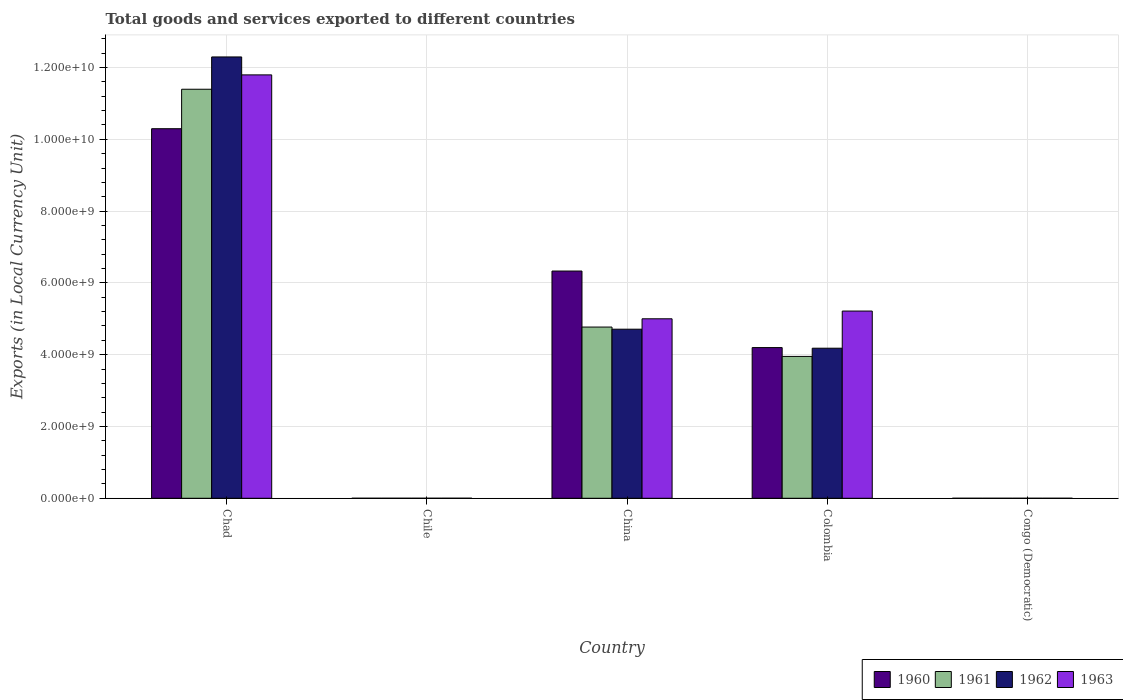How many different coloured bars are there?
Offer a very short reply. 4. How many groups of bars are there?
Make the answer very short. 5. Are the number of bars per tick equal to the number of legend labels?
Your response must be concise. Yes. How many bars are there on the 5th tick from the left?
Your answer should be very brief. 4. How many bars are there on the 2nd tick from the right?
Provide a succinct answer. 4. What is the label of the 4th group of bars from the left?
Provide a short and direct response. Colombia. What is the Amount of goods and services exports in 1960 in China?
Keep it short and to the point. 6.33e+09. Across all countries, what is the maximum Amount of goods and services exports in 1961?
Ensure brevity in your answer.  1.14e+1. Across all countries, what is the minimum Amount of goods and services exports in 1962?
Offer a terse response. 6.15126409684308e-5. In which country was the Amount of goods and services exports in 1960 maximum?
Make the answer very short. Chad. In which country was the Amount of goods and services exports in 1961 minimum?
Provide a succinct answer. Congo (Democratic). What is the total Amount of goods and services exports in 1962 in the graph?
Keep it short and to the point. 2.12e+1. What is the difference between the Amount of goods and services exports in 1961 in Chad and that in Colombia?
Keep it short and to the point. 7.44e+09. What is the difference between the Amount of goods and services exports in 1960 in Congo (Democratic) and the Amount of goods and services exports in 1961 in Chad?
Provide a succinct answer. -1.14e+1. What is the average Amount of goods and services exports in 1963 per country?
Offer a very short reply. 4.40e+09. What is the difference between the Amount of goods and services exports of/in 1960 and Amount of goods and services exports of/in 1961 in Chad?
Keep it short and to the point. -1.10e+09. In how many countries, is the Amount of goods and services exports in 1962 greater than 12000000000 LCU?
Provide a short and direct response. 1. What is the ratio of the Amount of goods and services exports in 1961 in Chile to that in China?
Keep it short and to the point. 0. What is the difference between the highest and the second highest Amount of goods and services exports in 1962?
Make the answer very short. 7.58e+09. What is the difference between the highest and the lowest Amount of goods and services exports in 1963?
Give a very brief answer. 1.18e+1. Is the sum of the Amount of goods and services exports in 1962 in China and Colombia greater than the maximum Amount of goods and services exports in 1961 across all countries?
Give a very brief answer. No. Is it the case that in every country, the sum of the Amount of goods and services exports in 1963 and Amount of goods and services exports in 1962 is greater than the Amount of goods and services exports in 1960?
Provide a succinct answer. Yes. What is the difference between two consecutive major ticks on the Y-axis?
Your answer should be compact. 2.00e+09. Are the values on the major ticks of Y-axis written in scientific E-notation?
Your response must be concise. Yes. Does the graph contain any zero values?
Your answer should be very brief. No. Does the graph contain grids?
Give a very brief answer. Yes. What is the title of the graph?
Offer a very short reply. Total goods and services exported to different countries. Does "1965" appear as one of the legend labels in the graph?
Make the answer very short. No. What is the label or title of the Y-axis?
Provide a short and direct response. Exports (in Local Currency Unit). What is the Exports (in Local Currency Unit) of 1960 in Chad?
Make the answer very short. 1.03e+1. What is the Exports (in Local Currency Unit) in 1961 in Chad?
Provide a short and direct response. 1.14e+1. What is the Exports (in Local Currency Unit) of 1962 in Chad?
Keep it short and to the point. 1.23e+1. What is the Exports (in Local Currency Unit) of 1963 in Chad?
Your answer should be compact. 1.18e+1. What is the Exports (in Local Currency Unit) in 1960 in Chile?
Offer a very short reply. 6.00e+05. What is the Exports (in Local Currency Unit) in 1963 in Chile?
Your answer should be very brief. 1.10e+06. What is the Exports (in Local Currency Unit) of 1960 in China?
Your answer should be compact. 6.33e+09. What is the Exports (in Local Currency Unit) of 1961 in China?
Offer a very short reply. 4.77e+09. What is the Exports (in Local Currency Unit) in 1962 in China?
Ensure brevity in your answer.  4.71e+09. What is the Exports (in Local Currency Unit) in 1963 in China?
Offer a very short reply. 5.00e+09. What is the Exports (in Local Currency Unit) of 1960 in Colombia?
Provide a short and direct response. 4.20e+09. What is the Exports (in Local Currency Unit) of 1961 in Colombia?
Provide a short and direct response. 3.95e+09. What is the Exports (in Local Currency Unit) of 1962 in Colombia?
Give a very brief answer. 4.18e+09. What is the Exports (in Local Currency Unit) of 1963 in Colombia?
Make the answer very short. 5.22e+09. What is the Exports (in Local Currency Unit) of 1960 in Congo (Democratic)?
Give a very brief answer. 0. What is the Exports (in Local Currency Unit) in 1961 in Congo (Democratic)?
Give a very brief answer. 5.32500016561244e-5. What is the Exports (in Local Currency Unit) of 1962 in Congo (Democratic)?
Make the answer very short. 6.15126409684308e-5. What is the Exports (in Local Currency Unit) of 1963 in Congo (Democratic)?
Give a very brief answer. 0. Across all countries, what is the maximum Exports (in Local Currency Unit) of 1960?
Your response must be concise. 1.03e+1. Across all countries, what is the maximum Exports (in Local Currency Unit) in 1961?
Offer a terse response. 1.14e+1. Across all countries, what is the maximum Exports (in Local Currency Unit) in 1962?
Provide a succinct answer. 1.23e+1. Across all countries, what is the maximum Exports (in Local Currency Unit) in 1963?
Your answer should be very brief. 1.18e+1. Across all countries, what is the minimum Exports (in Local Currency Unit) of 1960?
Provide a short and direct response. 0. Across all countries, what is the minimum Exports (in Local Currency Unit) of 1961?
Your answer should be compact. 5.32500016561244e-5. Across all countries, what is the minimum Exports (in Local Currency Unit) of 1962?
Give a very brief answer. 6.15126409684308e-5. Across all countries, what is the minimum Exports (in Local Currency Unit) of 1963?
Your response must be concise. 0. What is the total Exports (in Local Currency Unit) of 1960 in the graph?
Your response must be concise. 2.08e+1. What is the total Exports (in Local Currency Unit) in 1961 in the graph?
Offer a very short reply. 2.01e+1. What is the total Exports (in Local Currency Unit) of 1962 in the graph?
Make the answer very short. 2.12e+1. What is the total Exports (in Local Currency Unit) of 1963 in the graph?
Provide a short and direct response. 2.20e+1. What is the difference between the Exports (in Local Currency Unit) of 1960 in Chad and that in Chile?
Your response must be concise. 1.03e+1. What is the difference between the Exports (in Local Currency Unit) in 1961 in Chad and that in Chile?
Provide a short and direct response. 1.14e+1. What is the difference between the Exports (in Local Currency Unit) in 1962 in Chad and that in Chile?
Offer a terse response. 1.23e+1. What is the difference between the Exports (in Local Currency Unit) of 1963 in Chad and that in Chile?
Your answer should be compact. 1.18e+1. What is the difference between the Exports (in Local Currency Unit) in 1960 in Chad and that in China?
Your response must be concise. 3.97e+09. What is the difference between the Exports (in Local Currency Unit) of 1961 in Chad and that in China?
Offer a terse response. 6.62e+09. What is the difference between the Exports (in Local Currency Unit) of 1962 in Chad and that in China?
Keep it short and to the point. 7.58e+09. What is the difference between the Exports (in Local Currency Unit) in 1963 in Chad and that in China?
Provide a short and direct response. 6.79e+09. What is the difference between the Exports (in Local Currency Unit) in 1960 in Chad and that in Colombia?
Your answer should be compact. 6.10e+09. What is the difference between the Exports (in Local Currency Unit) in 1961 in Chad and that in Colombia?
Ensure brevity in your answer.  7.44e+09. What is the difference between the Exports (in Local Currency Unit) in 1962 in Chad and that in Colombia?
Your response must be concise. 8.11e+09. What is the difference between the Exports (in Local Currency Unit) of 1963 in Chad and that in Colombia?
Your response must be concise. 6.58e+09. What is the difference between the Exports (in Local Currency Unit) in 1960 in Chad and that in Congo (Democratic)?
Provide a succinct answer. 1.03e+1. What is the difference between the Exports (in Local Currency Unit) of 1961 in Chad and that in Congo (Democratic)?
Provide a succinct answer. 1.14e+1. What is the difference between the Exports (in Local Currency Unit) of 1962 in Chad and that in Congo (Democratic)?
Your answer should be very brief. 1.23e+1. What is the difference between the Exports (in Local Currency Unit) of 1963 in Chad and that in Congo (Democratic)?
Keep it short and to the point. 1.18e+1. What is the difference between the Exports (in Local Currency Unit) of 1960 in Chile and that in China?
Offer a terse response. -6.33e+09. What is the difference between the Exports (in Local Currency Unit) in 1961 in Chile and that in China?
Provide a short and direct response. -4.77e+09. What is the difference between the Exports (in Local Currency Unit) of 1962 in Chile and that in China?
Give a very brief answer. -4.71e+09. What is the difference between the Exports (in Local Currency Unit) of 1963 in Chile and that in China?
Provide a short and direct response. -5.00e+09. What is the difference between the Exports (in Local Currency Unit) of 1960 in Chile and that in Colombia?
Ensure brevity in your answer.  -4.20e+09. What is the difference between the Exports (in Local Currency Unit) in 1961 in Chile and that in Colombia?
Your answer should be compact. -3.95e+09. What is the difference between the Exports (in Local Currency Unit) in 1962 in Chile and that in Colombia?
Make the answer very short. -4.18e+09. What is the difference between the Exports (in Local Currency Unit) in 1963 in Chile and that in Colombia?
Offer a terse response. -5.21e+09. What is the difference between the Exports (in Local Currency Unit) of 1960 in Chile and that in Congo (Democratic)?
Your answer should be very brief. 6.00e+05. What is the difference between the Exports (in Local Currency Unit) in 1961 in Chile and that in Congo (Democratic)?
Ensure brevity in your answer.  6.00e+05. What is the difference between the Exports (in Local Currency Unit) in 1962 in Chile and that in Congo (Democratic)?
Provide a succinct answer. 7.00e+05. What is the difference between the Exports (in Local Currency Unit) of 1963 in Chile and that in Congo (Democratic)?
Your answer should be compact. 1.10e+06. What is the difference between the Exports (in Local Currency Unit) of 1960 in China and that in Colombia?
Make the answer very short. 2.13e+09. What is the difference between the Exports (in Local Currency Unit) of 1961 in China and that in Colombia?
Your answer should be compact. 8.18e+08. What is the difference between the Exports (in Local Currency Unit) of 1962 in China and that in Colombia?
Offer a terse response. 5.30e+08. What is the difference between the Exports (in Local Currency Unit) in 1963 in China and that in Colombia?
Give a very brief answer. -2.16e+08. What is the difference between the Exports (in Local Currency Unit) of 1960 in China and that in Congo (Democratic)?
Your answer should be compact. 6.33e+09. What is the difference between the Exports (in Local Currency Unit) of 1961 in China and that in Congo (Democratic)?
Your answer should be very brief. 4.77e+09. What is the difference between the Exports (in Local Currency Unit) in 1962 in China and that in Congo (Democratic)?
Offer a terse response. 4.71e+09. What is the difference between the Exports (in Local Currency Unit) in 1963 in China and that in Congo (Democratic)?
Your answer should be very brief. 5.00e+09. What is the difference between the Exports (in Local Currency Unit) of 1960 in Colombia and that in Congo (Democratic)?
Your response must be concise. 4.20e+09. What is the difference between the Exports (in Local Currency Unit) in 1961 in Colombia and that in Congo (Democratic)?
Provide a short and direct response. 3.95e+09. What is the difference between the Exports (in Local Currency Unit) of 1962 in Colombia and that in Congo (Democratic)?
Ensure brevity in your answer.  4.18e+09. What is the difference between the Exports (in Local Currency Unit) of 1963 in Colombia and that in Congo (Democratic)?
Give a very brief answer. 5.22e+09. What is the difference between the Exports (in Local Currency Unit) in 1960 in Chad and the Exports (in Local Currency Unit) in 1961 in Chile?
Ensure brevity in your answer.  1.03e+1. What is the difference between the Exports (in Local Currency Unit) of 1960 in Chad and the Exports (in Local Currency Unit) of 1962 in Chile?
Your response must be concise. 1.03e+1. What is the difference between the Exports (in Local Currency Unit) of 1960 in Chad and the Exports (in Local Currency Unit) of 1963 in Chile?
Keep it short and to the point. 1.03e+1. What is the difference between the Exports (in Local Currency Unit) in 1961 in Chad and the Exports (in Local Currency Unit) in 1962 in Chile?
Give a very brief answer. 1.14e+1. What is the difference between the Exports (in Local Currency Unit) in 1961 in Chad and the Exports (in Local Currency Unit) in 1963 in Chile?
Give a very brief answer. 1.14e+1. What is the difference between the Exports (in Local Currency Unit) in 1962 in Chad and the Exports (in Local Currency Unit) in 1963 in Chile?
Offer a very short reply. 1.23e+1. What is the difference between the Exports (in Local Currency Unit) of 1960 in Chad and the Exports (in Local Currency Unit) of 1961 in China?
Keep it short and to the point. 5.53e+09. What is the difference between the Exports (in Local Currency Unit) of 1960 in Chad and the Exports (in Local Currency Unit) of 1962 in China?
Provide a short and direct response. 5.59e+09. What is the difference between the Exports (in Local Currency Unit) in 1960 in Chad and the Exports (in Local Currency Unit) in 1963 in China?
Make the answer very short. 5.30e+09. What is the difference between the Exports (in Local Currency Unit) in 1961 in Chad and the Exports (in Local Currency Unit) in 1962 in China?
Provide a short and direct response. 6.68e+09. What is the difference between the Exports (in Local Currency Unit) in 1961 in Chad and the Exports (in Local Currency Unit) in 1963 in China?
Make the answer very short. 6.39e+09. What is the difference between the Exports (in Local Currency Unit) of 1962 in Chad and the Exports (in Local Currency Unit) of 1963 in China?
Keep it short and to the point. 7.29e+09. What is the difference between the Exports (in Local Currency Unit) of 1960 in Chad and the Exports (in Local Currency Unit) of 1961 in Colombia?
Ensure brevity in your answer.  6.34e+09. What is the difference between the Exports (in Local Currency Unit) of 1960 in Chad and the Exports (in Local Currency Unit) of 1962 in Colombia?
Offer a very short reply. 6.11e+09. What is the difference between the Exports (in Local Currency Unit) in 1960 in Chad and the Exports (in Local Currency Unit) in 1963 in Colombia?
Your response must be concise. 5.08e+09. What is the difference between the Exports (in Local Currency Unit) of 1961 in Chad and the Exports (in Local Currency Unit) of 1962 in Colombia?
Ensure brevity in your answer.  7.21e+09. What is the difference between the Exports (in Local Currency Unit) of 1961 in Chad and the Exports (in Local Currency Unit) of 1963 in Colombia?
Provide a short and direct response. 6.18e+09. What is the difference between the Exports (in Local Currency Unit) of 1962 in Chad and the Exports (in Local Currency Unit) of 1963 in Colombia?
Offer a terse response. 7.08e+09. What is the difference between the Exports (in Local Currency Unit) of 1960 in Chad and the Exports (in Local Currency Unit) of 1961 in Congo (Democratic)?
Make the answer very short. 1.03e+1. What is the difference between the Exports (in Local Currency Unit) of 1960 in Chad and the Exports (in Local Currency Unit) of 1962 in Congo (Democratic)?
Provide a succinct answer. 1.03e+1. What is the difference between the Exports (in Local Currency Unit) in 1960 in Chad and the Exports (in Local Currency Unit) in 1963 in Congo (Democratic)?
Give a very brief answer. 1.03e+1. What is the difference between the Exports (in Local Currency Unit) in 1961 in Chad and the Exports (in Local Currency Unit) in 1962 in Congo (Democratic)?
Keep it short and to the point. 1.14e+1. What is the difference between the Exports (in Local Currency Unit) in 1961 in Chad and the Exports (in Local Currency Unit) in 1963 in Congo (Democratic)?
Keep it short and to the point. 1.14e+1. What is the difference between the Exports (in Local Currency Unit) of 1962 in Chad and the Exports (in Local Currency Unit) of 1963 in Congo (Democratic)?
Ensure brevity in your answer.  1.23e+1. What is the difference between the Exports (in Local Currency Unit) of 1960 in Chile and the Exports (in Local Currency Unit) of 1961 in China?
Offer a terse response. -4.77e+09. What is the difference between the Exports (in Local Currency Unit) of 1960 in Chile and the Exports (in Local Currency Unit) of 1962 in China?
Keep it short and to the point. -4.71e+09. What is the difference between the Exports (in Local Currency Unit) in 1960 in Chile and the Exports (in Local Currency Unit) in 1963 in China?
Make the answer very short. -5.00e+09. What is the difference between the Exports (in Local Currency Unit) in 1961 in Chile and the Exports (in Local Currency Unit) in 1962 in China?
Provide a short and direct response. -4.71e+09. What is the difference between the Exports (in Local Currency Unit) of 1961 in Chile and the Exports (in Local Currency Unit) of 1963 in China?
Provide a short and direct response. -5.00e+09. What is the difference between the Exports (in Local Currency Unit) in 1962 in Chile and the Exports (in Local Currency Unit) in 1963 in China?
Give a very brief answer. -5.00e+09. What is the difference between the Exports (in Local Currency Unit) of 1960 in Chile and the Exports (in Local Currency Unit) of 1961 in Colombia?
Make the answer very short. -3.95e+09. What is the difference between the Exports (in Local Currency Unit) in 1960 in Chile and the Exports (in Local Currency Unit) in 1962 in Colombia?
Your answer should be compact. -4.18e+09. What is the difference between the Exports (in Local Currency Unit) in 1960 in Chile and the Exports (in Local Currency Unit) in 1963 in Colombia?
Ensure brevity in your answer.  -5.21e+09. What is the difference between the Exports (in Local Currency Unit) in 1961 in Chile and the Exports (in Local Currency Unit) in 1962 in Colombia?
Provide a short and direct response. -4.18e+09. What is the difference between the Exports (in Local Currency Unit) of 1961 in Chile and the Exports (in Local Currency Unit) of 1963 in Colombia?
Provide a succinct answer. -5.21e+09. What is the difference between the Exports (in Local Currency Unit) of 1962 in Chile and the Exports (in Local Currency Unit) of 1963 in Colombia?
Offer a very short reply. -5.21e+09. What is the difference between the Exports (in Local Currency Unit) in 1960 in Chile and the Exports (in Local Currency Unit) in 1961 in Congo (Democratic)?
Make the answer very short. 6.00e+05. What is the difference between the Exports (in Local Currency Unit) in 1960 in Chile and the Exports (in Local Currency Unit) in 1962 in Congo (Democratic)?
Offer a terse response. 6.00e+05. What is the difference between the Exports (in Local Currency Unit) in 1960 in Chile and the Exports (in Local Currency Unit) in 1963 in Congo (Democratic)?
Offer a terse response. 6.00e+05. What is the difference between the Exports (in Local Currency Unit) in 1961 in Chile and the Exports (in Local Currency Unit) in 1962 in Congo (Democratic)?
Your response must be concise. 6.00e+05. What is the difference between the Exports (in Local Currency Unit) in 1961 in Chile and the Exports (in Local Currency Unit) in 1963 in Congo (Democratic)?
Keep it short and to the point. 6.00e+05. What is the difference between the Exports (in Local Currency Unit) in 1962 in Chile and the Exports (in Local Currency Unit) in 1963 in Congo (Democratic)?
Provide a short and direct response. 7.00e+05. What is the difference between the Exports (in Local Currency Unit) in 1960 in China and the Exports (in Local Currency Unit) in 1961 in Colombia?
Your answer should be very brief. 2.38e+09. What is the difference between the Exports (in Local Currency Unit) in 1960 in China and the Exports (in Local Currency Unit) in 1962 in Colombia?
Provide a succinct answer. 2.15e+09. What is the difference between the Exports (in Local Currency Unit) in 1960 in China and the Exports (in Local Currency Unit) in 1963 in Colombia?
Offer a terse response. 1.11e+09. What is the difference between the Exports (in Local Currency Unit) of 1961 in China and the Exports (in Local Currency Unit) of 1962 in Colombia?
Keep it short and to the point. 5.90e+08. What is the difference between the Exports (in Local Currency Unit) of 1961 in China and the Exports (in Local Currency Unit) of 1963 in Colombia?
Offer a terse response. -4.46e+08. What is the difference between the Exports (in Local Currency Unit) of 1962 in China and the Exports (in Local Currency Unit) of 1963 in Colombia?
Ensure brevity in your answer.  -5.06e+08. What is the difference between the Exports (in Local Currency Unit) of 1960 in China and the Exports (in Local Currency Unit) of 1961 in Congo (Democratic)?
Your response must be concise. 6.33e+09. What is the difference between the Exports (in Local Currency Unit) in 1960 in China and the Exports (in Local Currency Unit) in 1962 in Congo (Democratic)?
Provide a short and direct response. 6.33e+09. What is the difference between the Exports (in Local Currency Unit) of 1960 in China and the Exports (in Local Currency Unit) of 1963 in Congo (Democratic)?
Keep it short and to the point. 6.33e+09. What is the difference between the Exports (in Local Currency Unit) in 1961 in China and the Exports (in Local Currency Unit) in 1962 in Congo (Democratic)?
Your answer should be very brief. 4.77e+09. What is the difference between the Exports (in Local Currency Unit) of 1961 in China and the Exports (in Local Currency Unit) of 1963 in Congo (Democratic)?
Provide a short and direct response. 4.77e+09. What is the difference between the Exports (in Local Currency Unit) of 1962 in China and the Exports (in Local Currency Unit) of 1963 in Congo (Democratic)?
Your answer should be compact. 4.71e+09. What is the difference between the Exports (in Local Currency Unit) of 1960 in Colombia and the Exports (in Local Currency Unit) of 1961 in Congo (Democratic)?
Your answer should be very brief. 4.20e+09. What is the difference between the Exports (in Local Currency Unit) of 1960 in Colombia and the Exports (in Local Currency Unit) of 1962 in Congo (Democratic)?
Provide a short and direct response. 4.20e+09. What is the difference between the Exports (in Local Currency Unit) in 1960 in Colombia and the Exports (in Local Currency Unit) in 1963 in Congo (Democratic)?
Ensure brevity in your answer.  4.20e+09. What is the difference between the Exports (in Local Currency Unit) in 1961 in Colombia and the Exports (in Local Currency Unit) in 1962 in Congo (Democratic)?
Give a very brief answer. 3.95e+09. What is the difference between the Exports (in Local Currency Unit) in 1961 in Colombia and the Exports (in Local Currency Unit) in 1963 in Congo (Democratic)?
Your response must be concise. 3.95e+09. What is the difference between the Exports (in Local Currency Unit) in 1962 in Colombia and the Exports (in Local Currency Unit) in 1963 in Congo (Democratic)?
Your response must be concise. 4.18e+09. What is the average Exports (in Local Currency Unit) of 1960 per country?
Your response must be concise. 4.16e+09. What is the average Exports (in Local Currency Unit) in 1961 per country?
Your answer should be compact. 4.02e+09. What is the average Exports (in Local Currency Unit) in 1962 per country?
Provide a succinct answer. 4.24e+09. What is the average Exports (in Local Currency Unit) in 1963 per country?
Offer a terse response. 4.40e+09. What is the difference between the Exports (in Local Currency Unit) of 1960 and Exports (in Local Currency Unit) of 1961 in Chad?
Ensure brevity in your answer.  -1.10e+09. What is the difference between the Exports (in Local Currency Unit) in 1960 and Exports (in Local Currency Unit) in 1962 in Chad?
Provide a succinct answer. -2.00e+09. What is the difference between the Exports (in Local Currency Unit) of 1960 and Exports (in Local Currency Unit) of 1963 in Chad?
Your answer should be compact. -1.50e+09. What is the difference between the Exports (in Local Currency Unit) in 1961 and Exports (in Local Currency Unit) in 1962 in Chad?
Make the answer very short. -9.00e+08. What is the difference between the Exports (in Local Currency Unit) of 1961 and Exports (in Local Currency Unit) of 1963 in Chad?
Make the answer very short. -4.00e+08. What is the difference between the Exports (in Local Currency Unit) in 1962 and Exports (in Local Currency Unit) in 1963 in Chad?
Provide a succinct answer. 5.00e+08. What is the difference between the Exports (in Local Currency Unit) in 1960 and Exports (in Local Currency Unit) in 1963 in Chile?
Your response must be concise. -5.00e+05. What is the difference between the Exports (in Local Currency Unit) of 1961 and Exports (in Local Currency Unit) of 1962 in Chile?
Offer a terse response. -1.00e+05. What is the difference between the Exports (in Local Currency Unit) in 1961 and Exports (in Local Currency Unit) in 1963 in Chile?
Your response must be concise. -5.00e+05. What is the difference between the Exports (in Local Currency Unit) of 1962 and Exports (in Local Currency Unit) of 1963 in Chile?
Offer a very short reply. -4.00e+05. What is the difference between the Exports (in Local Currency Unit) of 1960 and Exports (in Local Currency Unit) of 1961 in China?
Make the answer very short. 1.56e+09. What is the difference between the Exports (in Local Currency Unit) in 1960 and Exports (in Local Currency Unit) in 1962 in China?
Make the answer very short. 1.62e+09. What is the difference between the Exports (in Local Currency Unit) of 1960 and Exports (in Local Currency Unit) of 1963 in China?
Make the answer very short. 1.33e+09. What is the difference between the Exports (in Local Currency Unit) of 1961 and Exports (in Local Currency Unit) of 1962 in China?
Your answer should be very brief. 6.00e+07. What is the difference between the Exports (in Local Currency Unit) in 1961 and Exports (in Local Currency Unit) in 1963 in China?
Give a very brief answer. -2.30e+08. What is the difference between the Exports (in Local Currency Unit) of 1962 and Exports (in Local Currency Unit) of 1963 in China?
Make the answer very short. -2.90e+08. What is the difference between the Exports (in Local Currency Unit) in 1960 and Exports (in Local Currency Unit) in 1961 in Colombia?
Make the answer very short. 2.46e+08. What is the difference between the Exports (in Local Currency Unit) in 1960 and Exports (in Local Currency Unit) in 1962 in Colombia?
Your answer should be compact. 1.74e+07. What is the difference between the Exports (in Local Currency Unit) in 1960 and Exports (in Local Currency Unit) in 1963 in Colombia?
Make the answer very short. -1.02e+09. What is the difference between the Exports (in Local Currency Unit) in 1961 and Exports (in Local Currency Unit) in 1962 in Colombia?
Your answer should be compact. -2.28e+08. What is the difference between the Exports (in Local Currency Unit) in 1961 and Exports (in Local Currency Unit) in 1963 in Colombia?
Offer a very short reply. -1.26e+09. What is the difference between the Exports (in Local Currency Unit) in 1962 and Exports (in Local Currency Unit) in 1963 in Colombia?
Give a very brief answer. -1.04e+09. What is the difference between the Exports (in Local Currency Unit) in 1960 and Exports (in Local Currency Unit) in 1961 in Congo (Democratic)?
Give a very brief answer. 0. What is the difference between the Exports (in Local Currency Unit) of 1960 and Exports (in Local Currency Unit) of 1963 in Congo (Democratic)?
Your response must be concise. -0. What is the difference between the Exports (in Local Currency Unit) in 1961 and Exports (in Local Currency Unit) in 1963 in Congo (Democratic)?
Offer a terse response. -0. What is the difference between the Exports (in Local Currency Unit) of 1962 and Exports (in Local Currency Unit) of 1963 in Congo (Democratic)?
Keep it short and to the point. -0. What is the ratio of the Exports (in Local Currency Unit) in 1960 in Chad to that in Chile?
Offer a terse response. 1.72e+04. What is the ratio of the Exports (in Local Currency Unit) of 1961 in Chad to that in Chile?
Your answer should be compact. 1.90e+04. What is the ratio of the Exports (in Local Currency Unit) of 1962 in Chad to that in Chile?
Ensure brevity in your answer.  1.76e+04. What is the ratio of the Exports (in Local Currency Unit) of 1963 in Chad to that in Chile?
Your response must be concise. 1.07e+04. What is the ratio of the Exports (in Local Currency Unit) in 1960 in Chad to that in China?
Provide a short and direct response. 1.63. What is the ratio of the Exports (in Local Currency Unit) in 1961 in Chad to that in China?
Make the answer very short. 2.39. What is the ratio of the Exports (in Local Currency Unit) of 1962 in Chad to that in China?
Your response must be concise. 2.61. What is the ratio of the Exports (in Local Currency Unit) in 1963 in Chad to that in China?
Provide a succinct answer. 2.36. What is the ratio of the Exports (in Local Currency Unit) in 1960 in Chad to that in Colombia?
Make the answer very short. 2.45. What is the ratio of the Exports (in Local Currency Unit) in 1961 in Chad to that in Colombia?
Your answer should be very brief. 2.88. What is the ratio of the Exports (in Local Currency Unit) of 1962 in Chad to that in Colombia?
Your response must be concise. 2.94. What is the ratio of the Exports (in Local Currency Unit) in 1963 in Chad to that in Colombia?
Offer a terse response. 2.26. What is the ratio of the Exports (in Local Currency Unit) of 1960 in Chad to that in Congo (Democratic)?
Provide a succinct answer. 9.53e+13. What is the ratio of the Exports (in Local Currency Unit) of 1961 in Chad to that in Congo (Democratic)?
Ensure brevity in your answer.  2.14e+14. What is the ratio of the Exports (in Local Currency Unit) of 1962 in Chad to that in Congo (Democratic)?
Offer a terse response. 2.00e+14. What is the ratio of the Exports (in Local Currency Unit) in 1963 in Chad to that in Congo (Democratic)?
Offer a very short reply. 2.36e+13. What is the ratio of the Exports (in Local Currency Unit) in 1961 in Chile to that in China?
Give a very brief answer. 0. What is the ratio of the Exports (in Local Currency Unit) in 1962 in Chile to that in Colombia?
Provide a succinct answer. 0. What is the ratio of the Exports (in Local Currency Unit) in 1963 in Chile to that in Colombia?
Provide a succinct answer. 0. What is the ratio of the Exports (in Local Currency Unit) of 1960 in Chile to that in Congo (Democratic)?
Offer a very short reply. 5.55e+09. What is the ratio of the Exports (in Local Currency Unit) of 1961 in Chile to that in Congo (Democratic)?
Provide a succinct answer. 1.13e+1. What is the ratio of the Exports (in Local Currency Unit) of 1962 in Chile to that in Congo (Democratic)?
Your answer should be compact. 1.14e+1. What is the ratio of the Exports (in Local Currency Unit) of 1963 in Chile to that in Congo (Democratic)?
Offer a terse response. 2.21e+09. What is the ratio of the Exports (in Local Currency Unit) in 1960 in China to that in Colombia?
Your response must be concise. 1.51. What is the ratio of the Exports (in Local Currency Unit) in 1961 in China to that in Colombia?
Your response must be concise. 1.21. What is the ratio of the Exports (in Local Currency Unit) in 1962 in China to that in Colombia?
Provide a short and direct response. 1.13. What is the ratio of the Exports (in Local Currency Unit) of 1963 in China to that in Colombia?
Your response must be concise. 0.96. What is the ratio of the Exports (in Local Currency Unit) in 1960 in China to that in Congo (Democratic)?
Offer a very short reply. 5.86e+13. What is the ratio of the Exports (in Local Currency Unit) of 1961 in China to that in Congo (Democratic)?
Your answer should be very brief. 8.96e+13. What is the ratio of the Exports (in Local Currency Unit) of 1962 in China to that in Congo (Democratic)?
Provide a succinct answer. 7.66e+13. What is the ratio of the Exports (in Local Currency Unit) in 1963 in China to that in Congo (Democratic)?
Offer a very short reply. 1.00e+13. What is the ratio of the Exports (in Local Currency Unit) in 1960 in Colombia to that in Congo (Democratic)?
Your answer should be very brief. 3.89e+13. What is the ratio of the Exports (in Local Currency Unit) in 1961 in Colombia to that in Congo (Democratic)?
Make the answer very short. 7.42e+13. What is the ratio of the Exports (in Local Currency Unit) of 1962 in Colombia to that in Congo (Democratic)?
Provide a succinct answer. 6.80e+13. What is the ratio of the Exports (in Local Currency Unit) of 1963 in Colombia to that in Congo (Democratic)?
Provide a short and direct response. 1.05e+13. What is the difference between the highest and the second highest Exports (in Local Currency Unit) in 1960?
Your answer should be very brief. 3.97e+09. What is the difference between the highest and the second highest Exports (in Local Currency Unit) of 1961?
Your response must be concise. 6.62e+09. What is the difference between the highest and the second highest Exports (in Local Currency Unit) in 1962?
Your answer should be compact. 7.58e+09. What is the difference between the highest and the second highest Exports (in Local Currency Unit) of 1963?
Your response must be concise. 6.58e+09. What is the difference between the highest and the lowest Exports (in Local Currency Unit) of 1960?
Give a very brief answer. 1.03e+1. What is the difference between the highest and the lowest Exports (in Local Currency Unit) in 1961?
Make the answer very short. 1.14e+1. What is the difference between the highest and the lowest Exports (in Local Currency Unit) of 1962?
Provide a short and direct response. 1.23e+1. What is the difference between the highest and the lowest Exports (in Local Currency Unit) of 1963?
Offer a very short reply. 1.18e+1. 